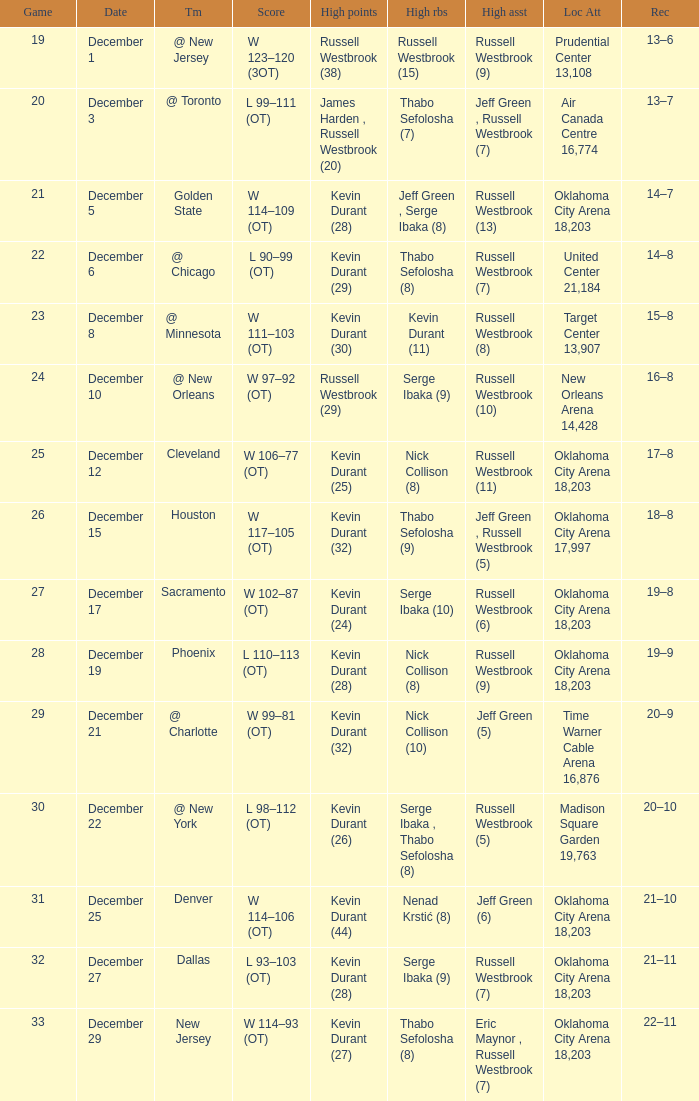Who had the high rebounds record on December 12? Nick Collison (8). 